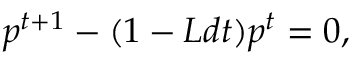Convert formula to latex. <formula><loc_0><loc_0><loc_500><loc_500>p ^ { t + 1 } - ( 1 - L d t ) p ^ { t } = 0 ,</formula> 